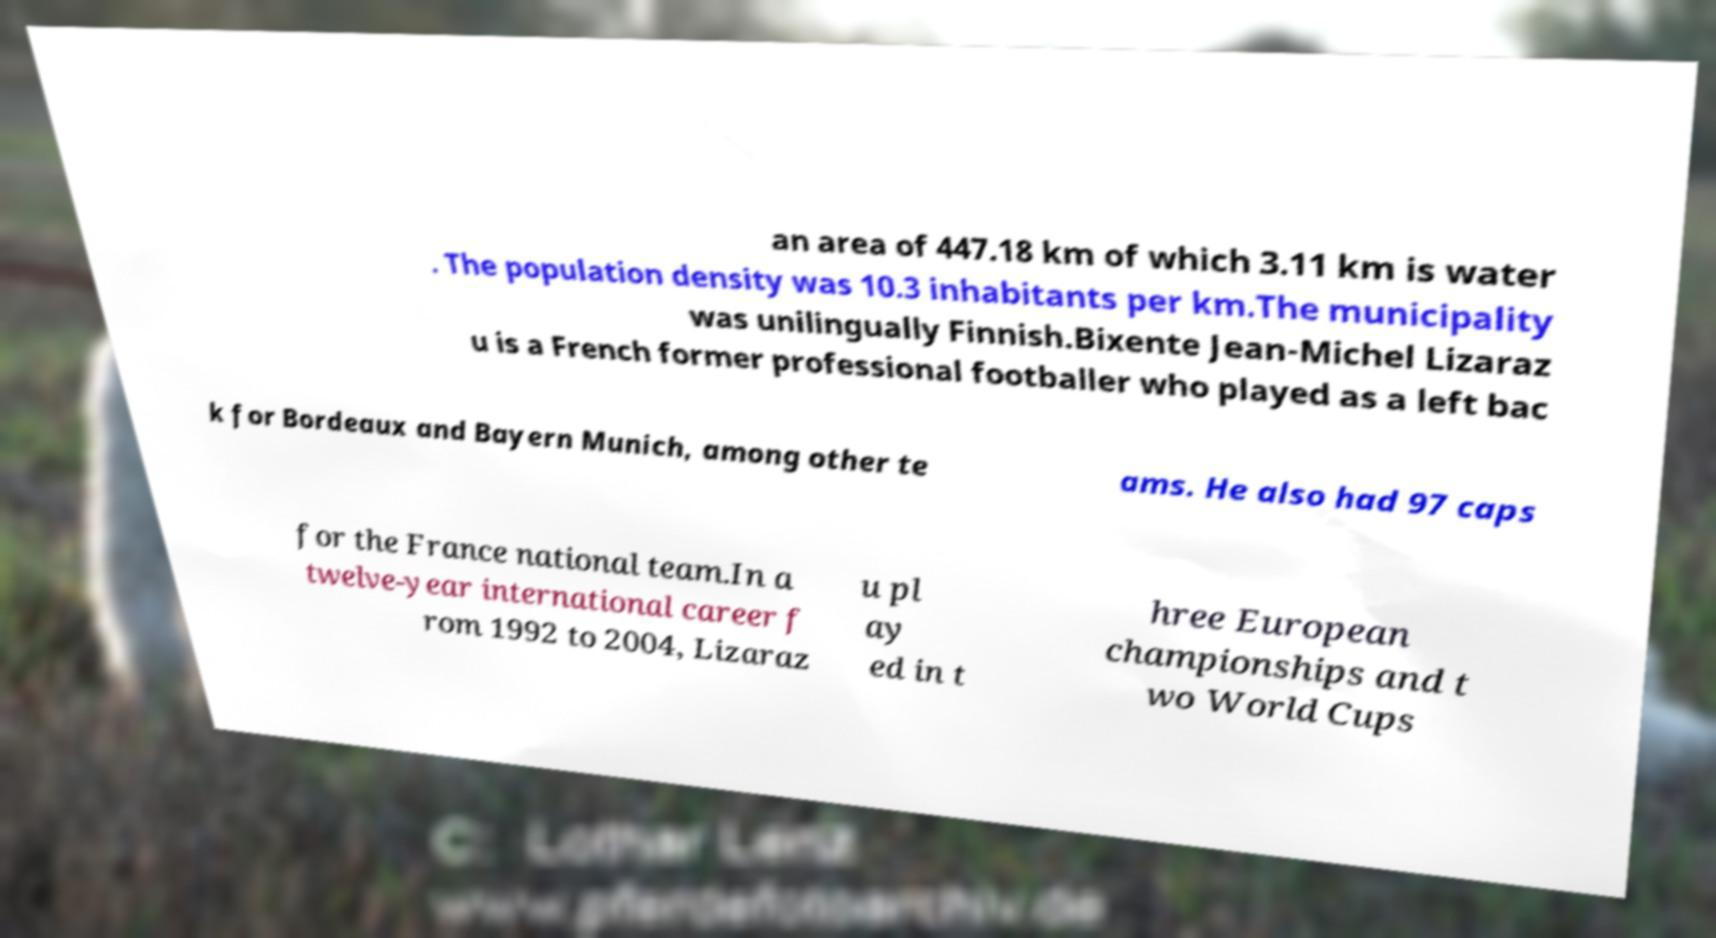What messages or text are displayed in this image? I need them in a readable, typed format. an area of 447.18 km of which 3.11 km is water . The population density was 10.3 inhabitants per km.The municipality was unilingually Finnish.Bixente Jean-Michel Lizaraz u is a French former professional footballer who played as a left bac k for Bordeaux and Bayern Munich, among other te ams. He also had 97 caps for the France national team.In a twelve-year international career f rom 1992 to 2004, Lizaraz u pl ay ed in t hree European championships and t wo World Cups 